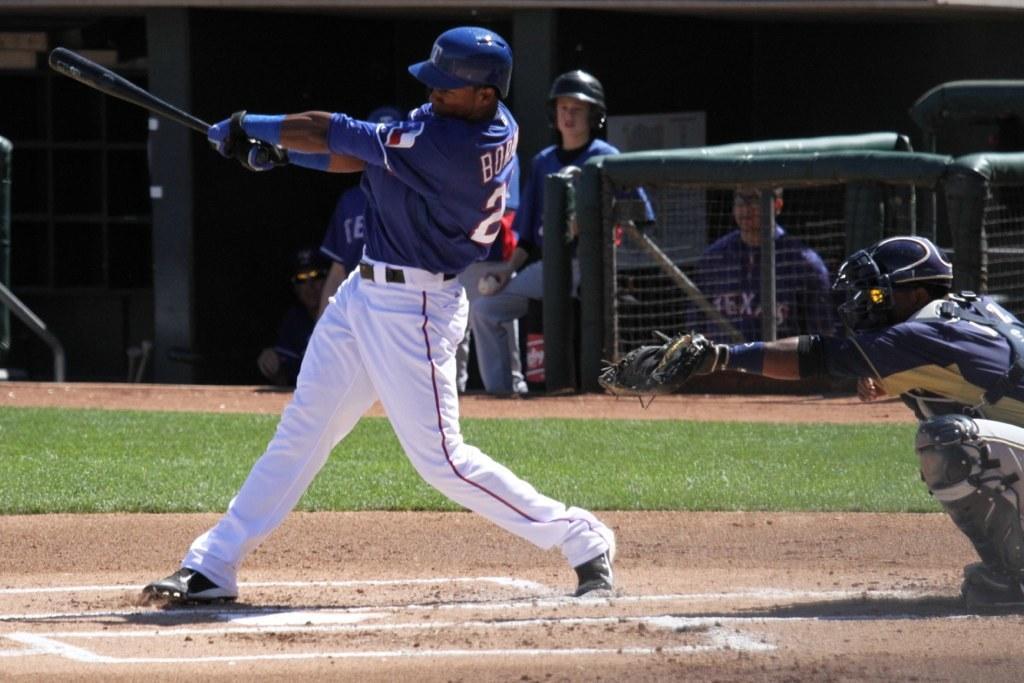Can you describe this image briefly? In the middle of the image a person is standing and swinging a baseball bat. Behind him we can see grass and fencing. Behind the fencing few people are standing and sitting. At the top of the image we can see wall. In the bottom right corner of the image a person is sitting and watching. 